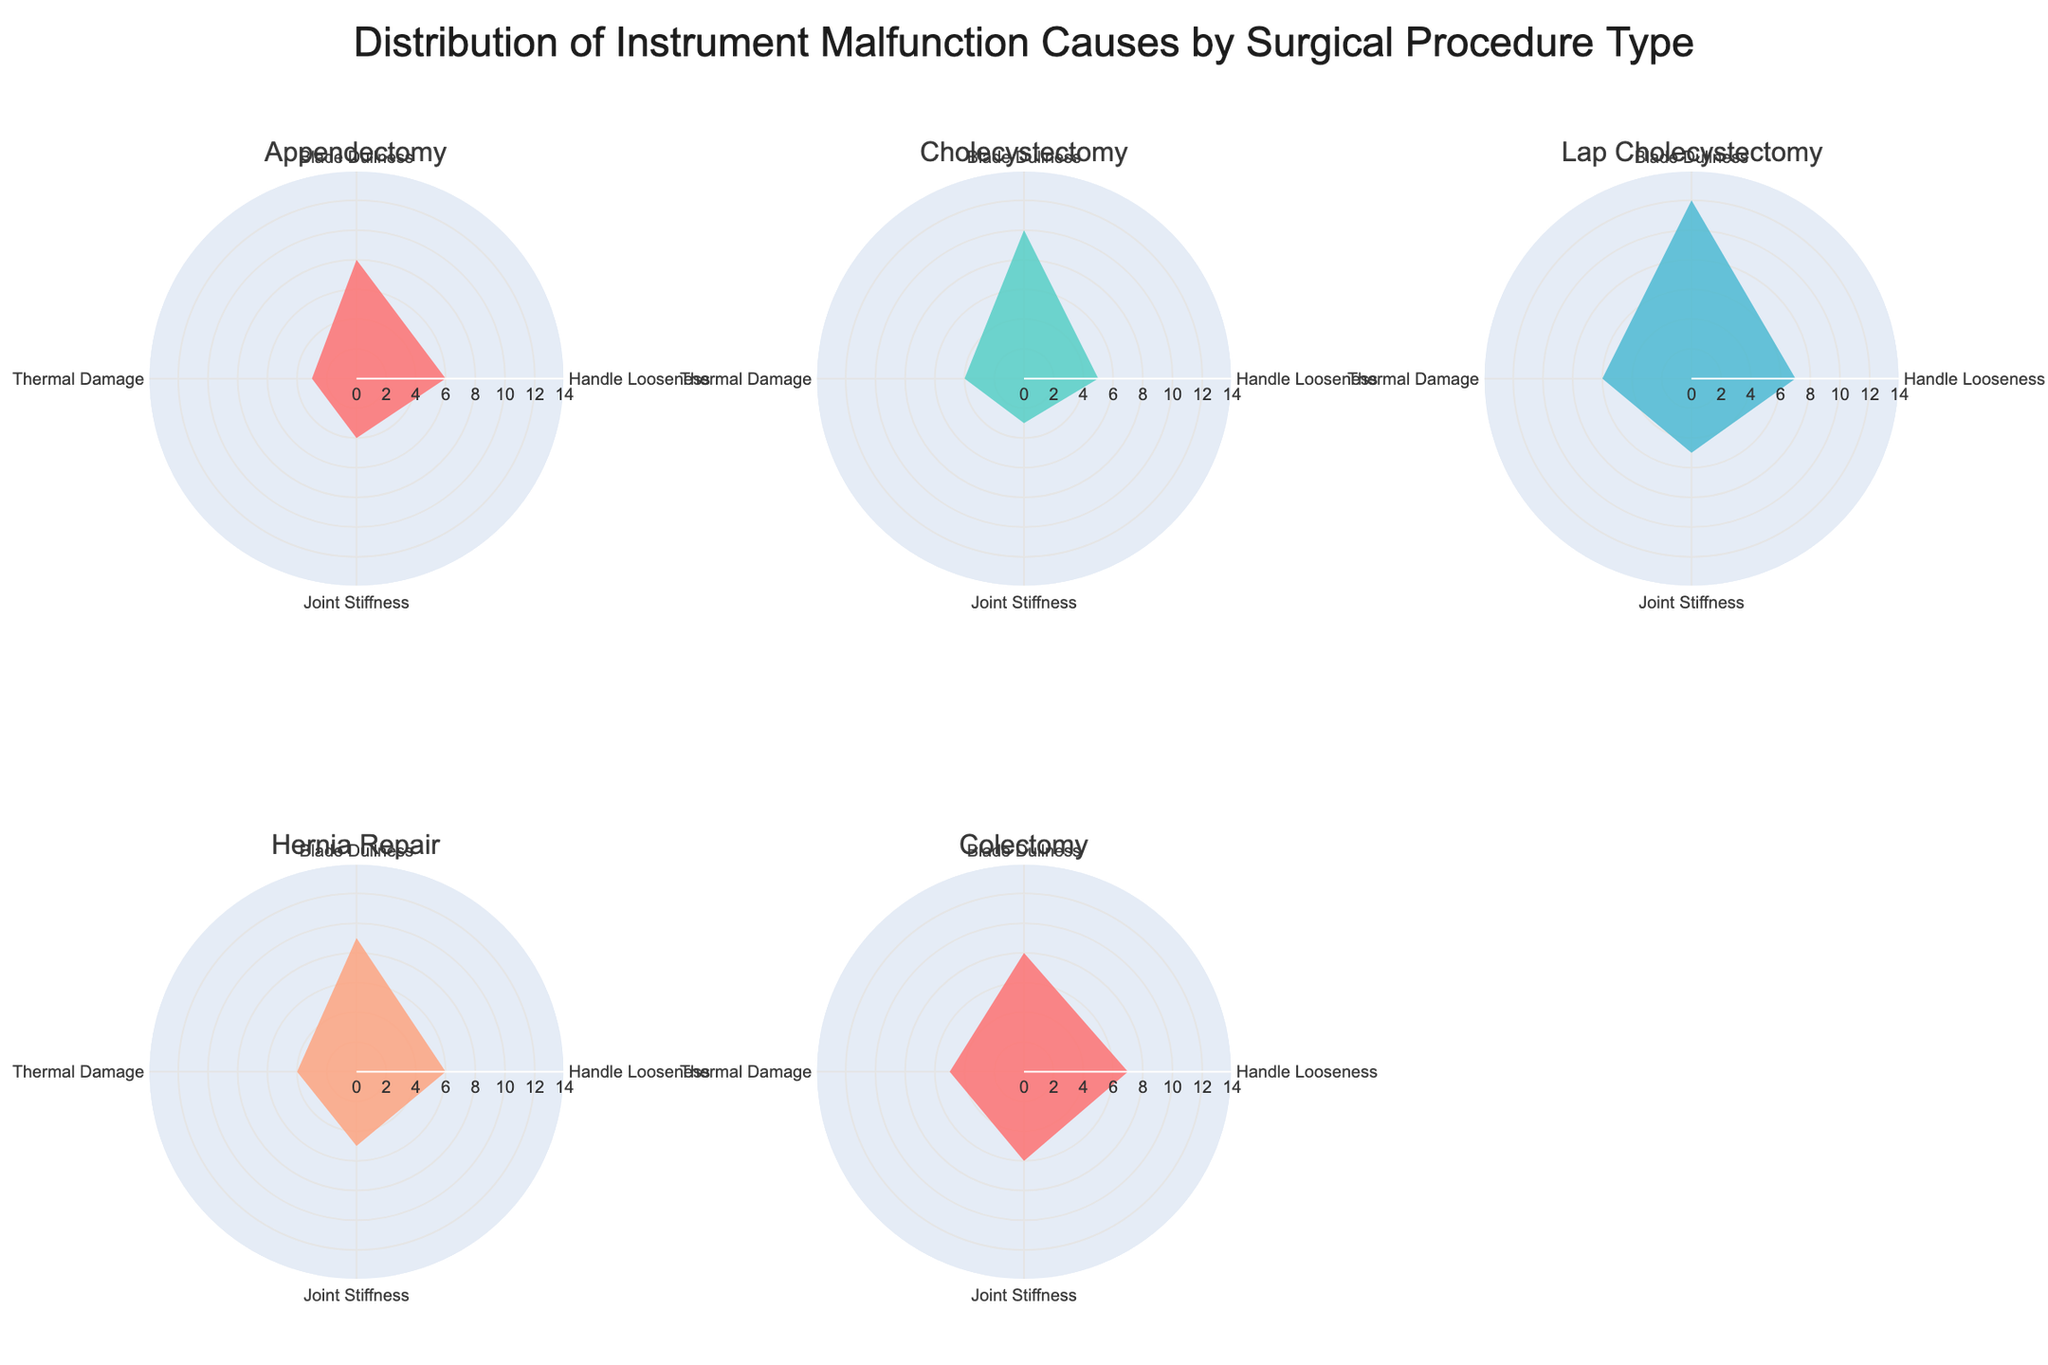What is the total number of malfunctions for Appendectomy? Add the counts of all the causes for Appendectomy: 8 (Blade Dullness) + 6 (Handle Looseness) + 4 (Joint Stiffness) + 3 (Thermal Damage) = 21
Answer: 21 Which procedure type has the highest count for Blade Dullness? Compare the counts for Blade Dullness across all procedure types: Appendectomy (8), Cholecystectomy (10), Lap Cholecystectomy (12), Hernia Repair (9), Colectomy (8). The highest count is 12 for Lap Cholecystectomy
Answer: Lap Cholecystectomy How does Handle Looseness in Colectomy compare to Lap Cholecystectomy? Handle Looseness counts: Colectomy (7) and Lap Cholecystectomy (7). Both are equal with a count of 7
Answer: They are equal What is the average count of Thermal Damage across all procedure types? Sum the Thermal Damage counts: 3 (Appendectomy) + 4 (Cholecystectomy) + 6 (Lap Cholecystectomy) + 4 (Hernia Repair) + 5 (Colectomy) = 22. Divide by the number of procedure types (5): 22 / 5 = 4.4
Answer: 4.4 Which procedure type has the smallest total count of malfunctions, and what is the count? Sum the counts for each procedure type and identify the smallest:
- Appendectomy: 8 + 6 + 4 + 3 = 21
- Cholecystectomy: 10 + 5 + 3 + 4 = 22
- Lap Cholecystectomy: 12 + 7 + 5 + 6 = 30
- Hernia Repair: 9 + 6 + 5 + 4 = 24
- Colectomy: 8 + 7 + 6 + 5 = 26. The smallest total count is 21 for Appendectomy
Answer: Appendectomy, 21 Which cause of malfunction has the most consistent count across all procedure types? Identify the cause with the least variance in counts. Blade Dullness varies significantly, Handle Looseness varies slightly less, Joint Stiffness varies moderately, and Thermal Damage has a relatively consistent count (3, 4, 6, 4, 5) with a small range difference (2). Thermal Damage is the most consistent
Answer: Thermal Damage What is the combined count for Joint Stiffness and Thermal Damage in Hernia Repair? Add the counts for both causes in Hernia Repair: 5 (Joint Stiffness) + 4 (Thermal Damage) = 9
Answer: 9 Which surgical procedure has a higher count for Joint Stiffness, Appendectomy or Colectomy? Compare the Joint Stiffness counts: Appendectomy (4) and Colectomy (6). Colectomy has a higher count
Answer: Colectomy What is the overall proportion of Handle Looseness in Lap Cholecystectomy relative to the total malfunction counts for that procedure? Calculate the proportion for Lap Cholecystectomy: 7 (Handle Looseness) / 30 (Total for Lap Cholecystectomy) = 7/30 ≈ 0.233 or 23.3%
Answer: 23.3% 